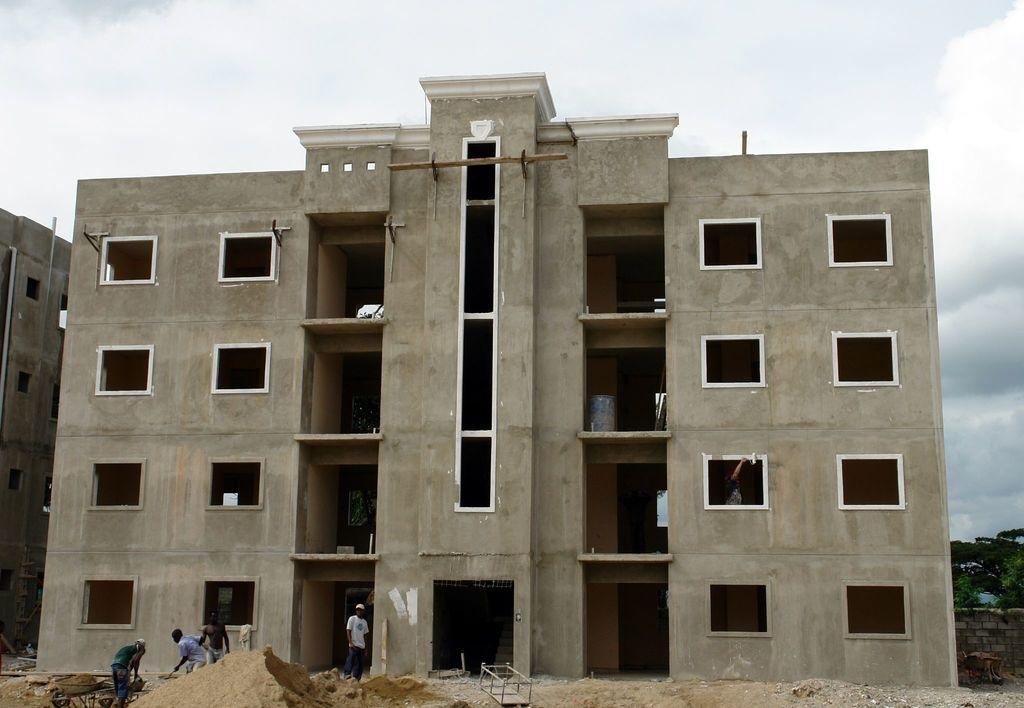What type of structures can be seen in the image? There are buildings in the image. What object is related to water in the image? There is a water drum in the image. What material is present in the image that is typically found on beaches? Sand is present in the image. What mode of transportation is visible in the image? There is a cart in the image. Are there any living beings in the image? Yes, there are people in the image. What architectural feature can be seen in the image? There is a wall in the image. What type of vegetation is present in the image? There are trees in the image. What part of the natural environment is visible in the background of the image? The sky is visible in the background of the image, and there are clouds in the sky. How many cows are grazing in the image? There are no cows present in the image. What type of plants are being destroyed by the people in the image? There is no destruction or plant-related activity depicted in the image. 